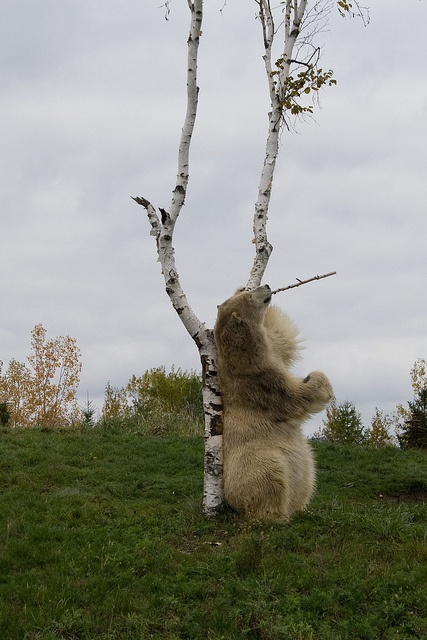Describe the objects in this image and their specific colors. I can see a bear in lightgray, gray, and black tones in this image. 